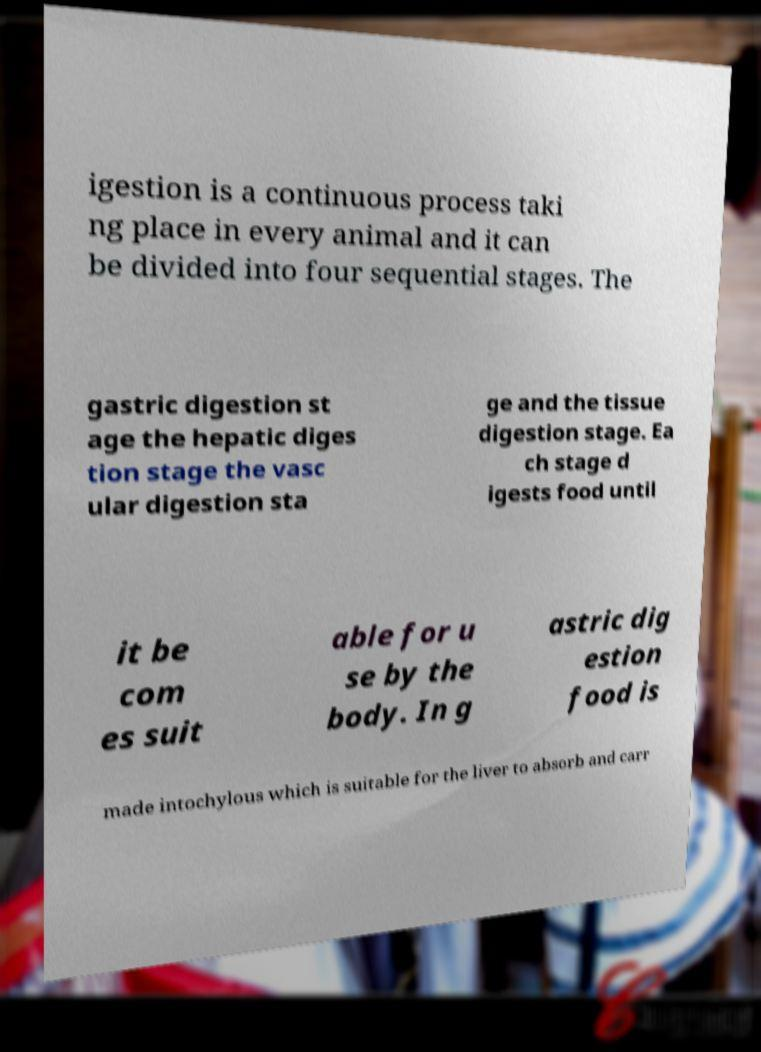What messages or text are displayed in this image? I need them in a readable, typed format. igestion is a continuous process taki ng place in every animal and it can be divided into four sequential stages. The gastric digestion st age the hepatic diges tion stage the vasc ular digestion sta ge and the tissue digestion stage. Ea ch stage d igests food until it be com es suit able for u se by the body. In g astric dig estion food is made intochylous which is suitable for the liver to absorb and carr 